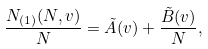<formula> <loc_0><loc_0><loc_500><loc_500>\frac { N _ { ( 1 ) } ( N , v ) } { N } & = \tilde { A } ( v ) + \frac { \tilde { B } ( v ) } { N } ,</formula> 